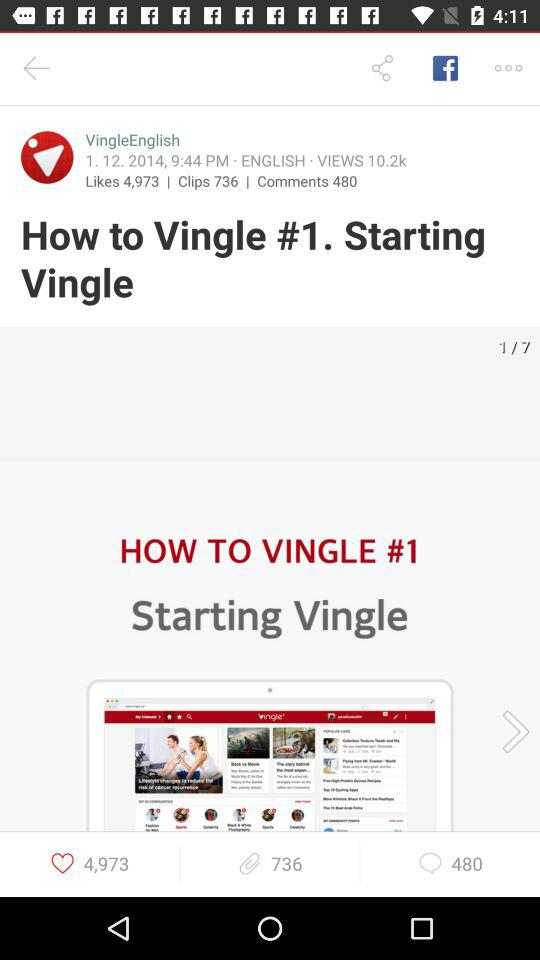What's the number of comments? The number of comments is 480. 